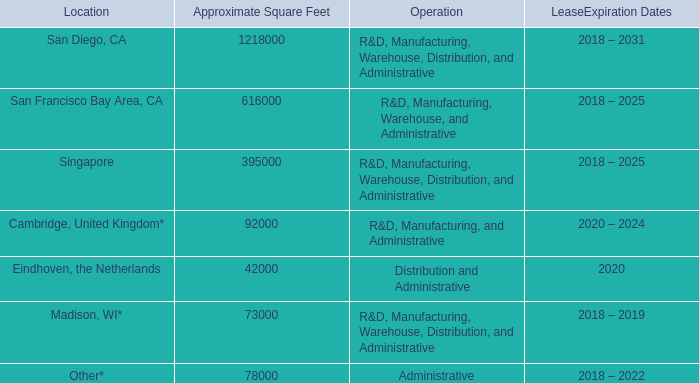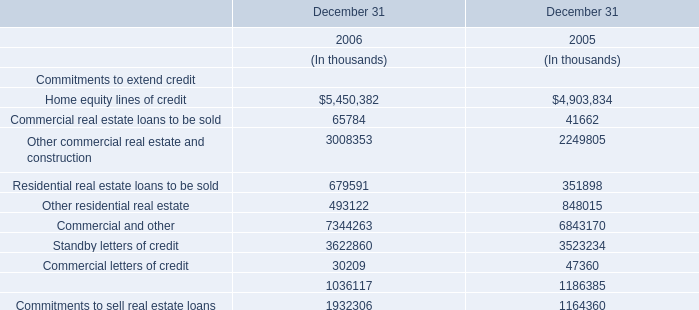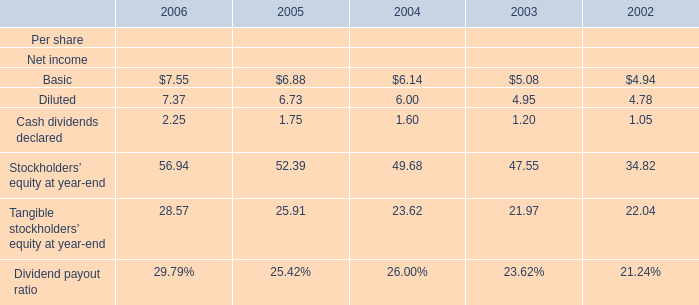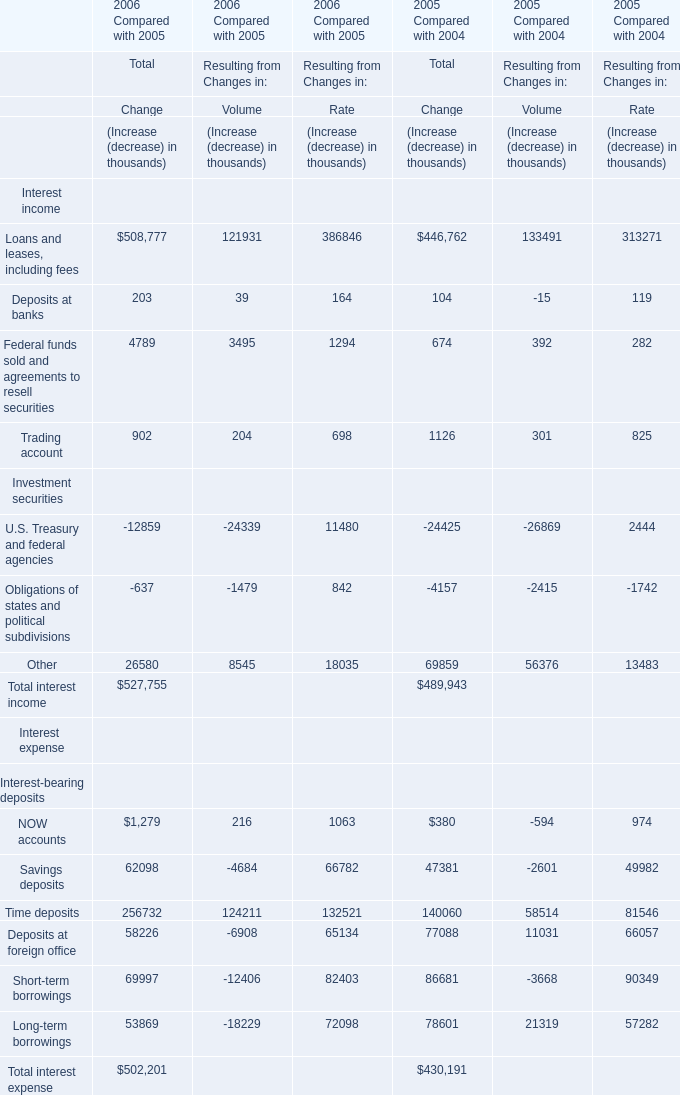What's the average of the Stockholders'equity at year-end for Net income in the years where Other residential real estate for Commitments to extend credit is positive? 
Computations: ((56.94 + 52.39) / 2)
Answer: 54.665. 